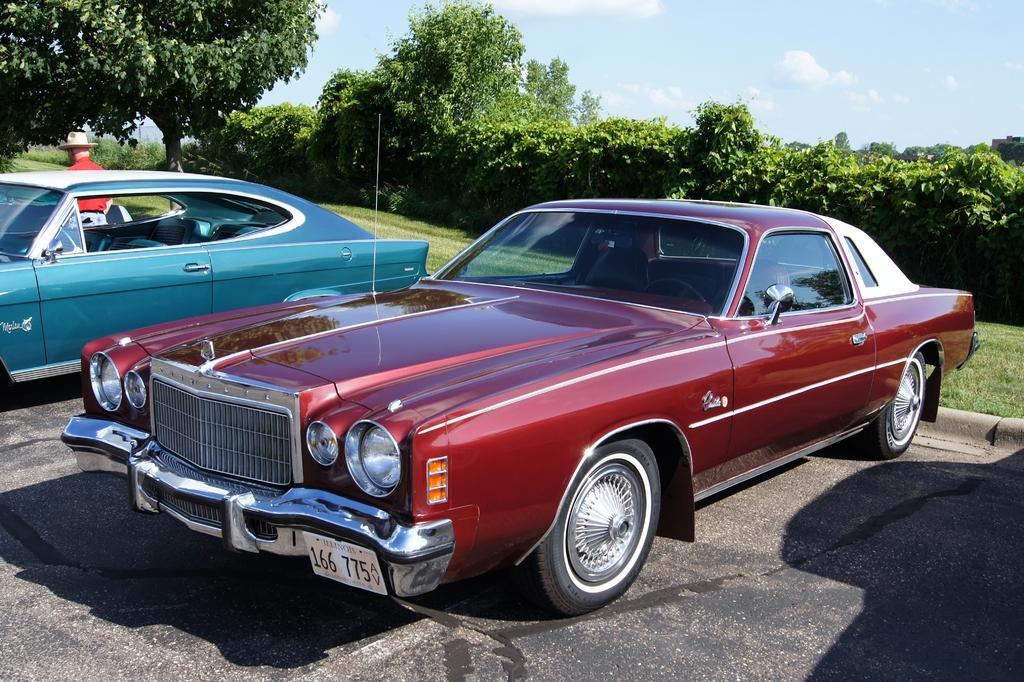Can you describe this image briefly? There are two cars. Near to the car there is a person wearing hat is standing. In the back there are trees and sky with clouds. On the ground there is grass. 